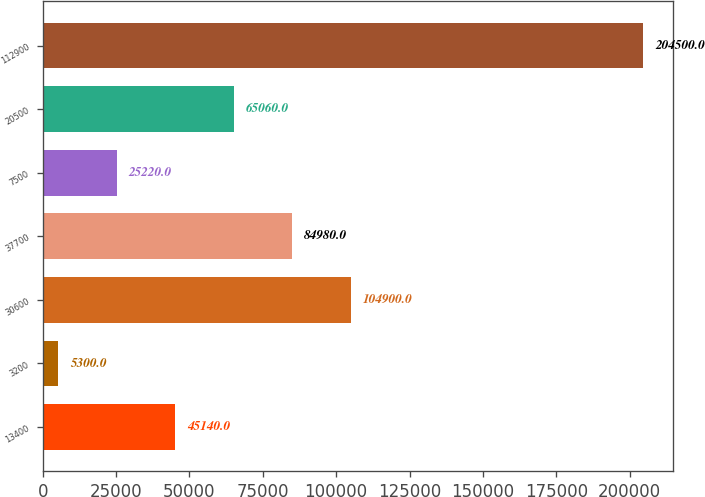<chart> <loc_0><loc_0><loc_500><loc_500><bar_chart><fcel>13400<fcel>3200<fcel>30600<fcel>37700<fcel>7500<fcel>20500<fcel>112900<nl><fcel>45140<fcel>5300<fcel>104900<fcel>84980<fcel>25220<fcel>65060<fcel>204500<nl></chart> 